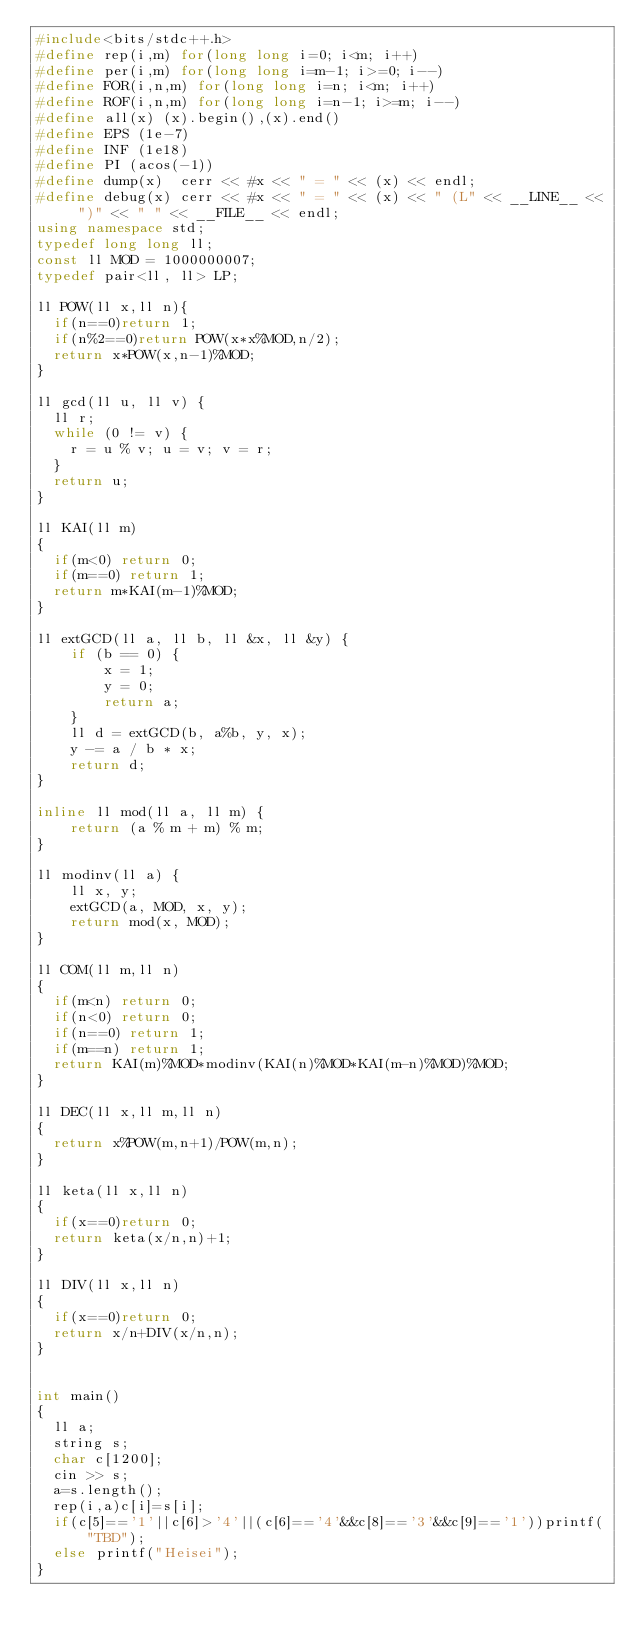Convert code to text. <code><loc_0><loc_0><loc_500><loc_500><_C++_>#include<bits/stdc++.h>
#define rep(i,m) for(long long i=0; i<m; i++)
#define per(i,m) for(long long i=m-1; i>=0; i--)
#define FOR(i,n,m) for(long long i=n; i<m; i++)
#define ROF(i,n,m) for(long long i=n-1; i>=m; i--)
#define all(x) (x).begin(),(x).end()
#define EPS (1e-7)
#define INF (1e18)
#define PI (acos(-1))
#define dump(x)  cerr << #x << " = " << (x) << endl;
#define debug(x) cerr << #x << " = " << (x) << " (L" << __LINE__ << ")" << " " << __FILE__ << endl;
using namespace std;
typedef long long ll;
const ll MOD = 1000000007;
typedef pair<ll, ll> LP;

ll POW(ll x,ll n){
  if(n==0)return 1;
  if(n%2==0)return POW(x*x%MOD,n/2);
  return x*POW(x,n-1)%MOD;
}

ll gcd(ll u, ll v) {
  ll r;
  while (0 != v) {
    r = u % v; u = v; v = r;
  }
  return u;
}
 
ll KAI(ll m)
{
  if(m<0) return 0;
  if(m==0) return 1;
  return m*KAI(m-1)%MOD;
}
 
ll extGCD(ll a, ll b, ll &x, ll &y) {
    if (b == 0) {
        x = 1;
        y = 0;
        return a;
    }
    ll d = extGCD(b, a%b, y, x);
    y -= a / b * x;
    return d;
}
 
inline ll mod(ll a, ll m) {
    return (a % m + m) % m;
}
 
ll modinv(ll a) {
    ll x, y;
    extGCD(a, MOD, x, y);
    return mod(x, MOD);
}
 
ll COM(ll m,ll n)
{
  if(m<n) return 0;
  if(n<0) return 0;
  if(n==0) return 1;
  if(m==n) return 1;
  return KAI(m)%MOD*modinv(KAI(n)%MOD*KAI(m-n)%MOD)%MOD;
}

ll DEC(ll x,ll m,ll n)
{
  return x%POW(m,n+1)/POW(m,n);
}

ll keta(ll x,ll n)
{
  if(x==0)return 0;
  return keta(x/n,n)+1;
}

ll DIV(ll x,ll n)
{
  if(x==0)return 0;
  return x/n+DIV(x/n,n);
}


int main()
{
  ll a;
  string s;
  char c[1200];
  cin >> s;
  a=s.length();
  rep(i,a)c[i]=s[i];
  if(c[5]=='1'||c[6]>'4'||(c[6]=='4'&&c[8]=='3'&&c[9]=='1'))printf("TBD");
  else printf("Heisei");
}</code> 